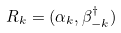Convert formula to latex. <formula><loc_0><loc_0><loc_500><loc_500>R _ { k } = ( \alpha _ { k } , \beta _ { - { k } } ^ { \dagger } )</formula> 